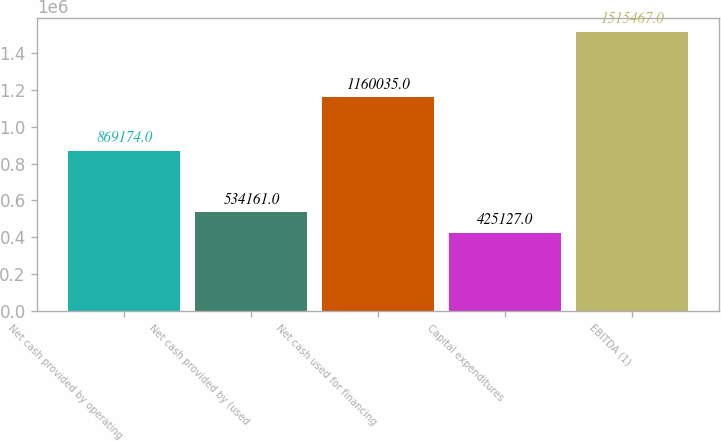Convert chart to OTSL. <chart><loc_0><loc_0><loc_500><loc_500><bar_chart><fcel>Net cash provided by operating<fcel>Net cash provided by (used<fcel>Net cash used for financing<fcel>Capital expenditures<fcel>EBITDA (1)<nl><fcel>869174<fcel>534161<fcel>1.16004e+06<fcel>425127<fcel>1.51547e+06<nl></chart> 